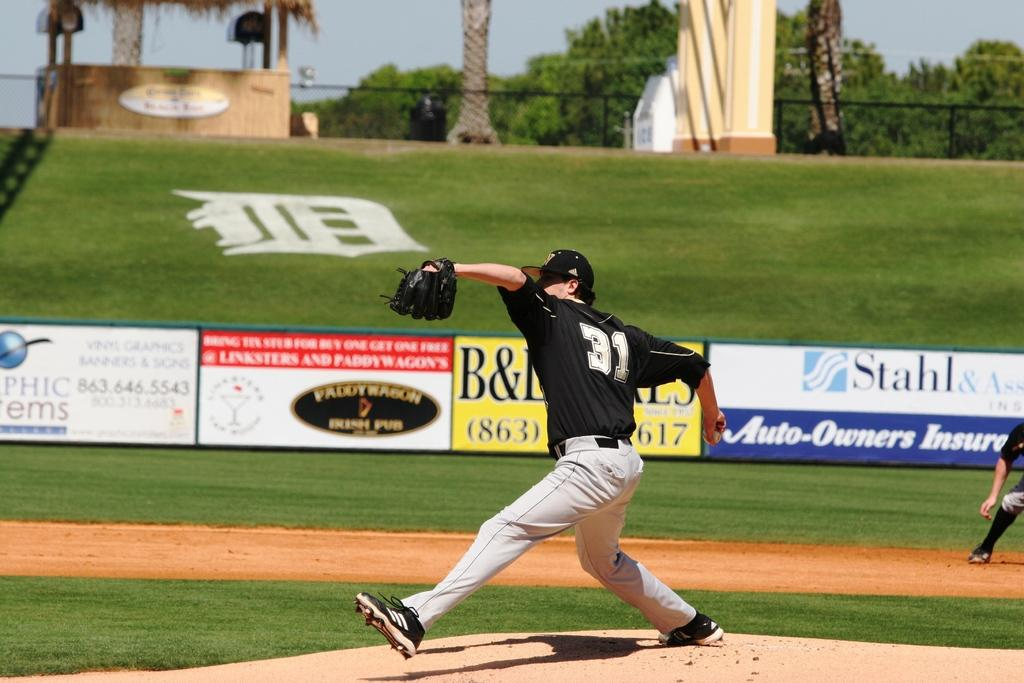<image>
Relay a brief, clear account of the picture shown. The pitcher wears number 31 and is about to release the baseball. 